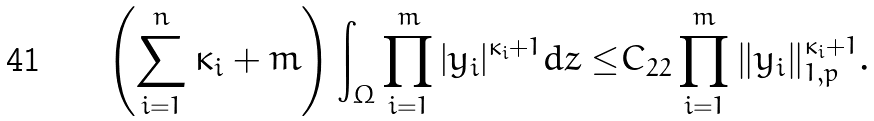Convert formula to latex. <formula><loc_0><loc_0><loc_500><loc_500>\left ( \sum _ { i = 1 } ^ { n } \kappa _ { i } + m \right ) \int _ { \Omega } \prod _ { i = 1 } ^ { m } | y _ { i } | ^ { \kappa _ { i } + 1 } d z \leq & C _ { 2 2 } \prod _ { i = 1 } ^ { m } \| y _ { i } \| _ { 1 , p } ^ { \kappa _ { i } + 1 } .</formula> 